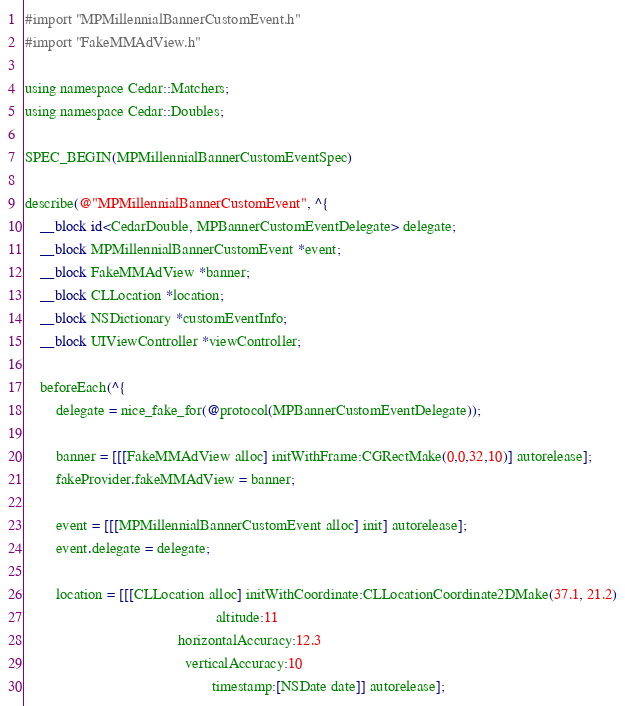Convert code to text. <code><loc_0><loc_0><loc_500><loc_500><_ObjectiveC_>#import "MPMillennialBannerCustomEvent.h"
#import "FakeMMAdView.h"

using namespace Cedar::Matchers;
using namespace Cedar::Doubles;

SPEC_BEGIN(MPMillennialBannerCustomEventSpec)

describe(@"MPMillennialBannerCustomEvent", ^{
    __block id<CedarDouble, MPBannerCustomEventDelegate> delegate;
    __block MPMillennialBannerCustomEvent *event;
    __block FakeMMAdView *banner;
    __block CLLocation *location;
    __block NSDictionary *customEventInfo;
    __block UIViewController *viewController;

    beforeEach(^{
        delegate = nice_fake_for(@protocol(MPBannerCustomEventDelegate));

        banner = [[[FakeMMAdView alloc] initWithFrame:CGRectMake(0,0,32,10)] autorelease];
        fakeProvider.fakeMMAdView = banner;

        event = [[[MPMillennialBannerCustomEvent alloc] init] autorelease];
        event.delegate = delegate;

        location = [[[CLLocation alloc] initWithCoordinate:CLLocationCoordinate2DMake(37.1, 21.2)
                                                  altitude:11
                                        horizontalAccuracy:12.3
                                          verticalAccuracy:10
                                                 timestamp:[NSDate date]] autorelease];</code> 